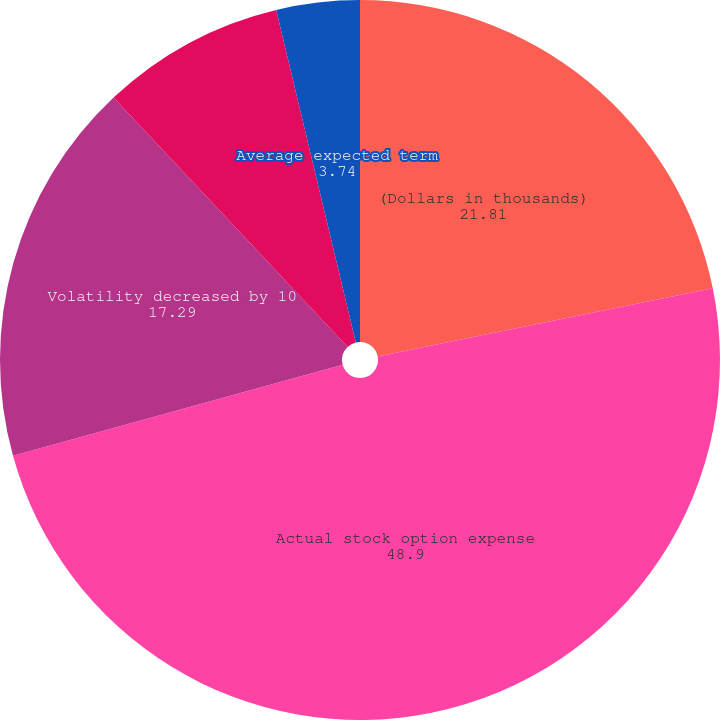Convert chart to OTSL. <chart><loc_0><loc_0><loc_500><loc_500><pie_chart><fcel>(Dollars in thousands)<fcel>Actual stock option expense<fcel>Volatility decreased by 10<fcel>Volatility increased by 10<fcel>Average expected term<nl><fcel>21.81%<fcel>48.9%<fcel>17.29%<fcel>8.26%<fcel>3.74%<nl></chart> 